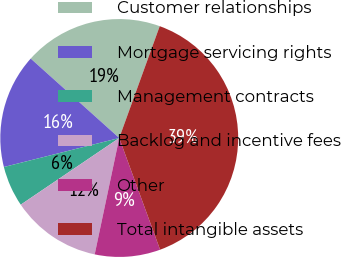Convert chart. <chart><loc_0><loc_0><loc_500><loc_500><pie_chart><fcel>Customer relationships<fcel>Mortgage servicing rights<fcel>Management contracts<fcel>Backlog and incentive fees<fcel>Other<fcel>Total intangible assets<nl><fcel>18.89%<fcel>15.56%<fcel>5.55%<fcel>12.22%<fcel>8.89%<fcel>38.89%<nl></chart> 